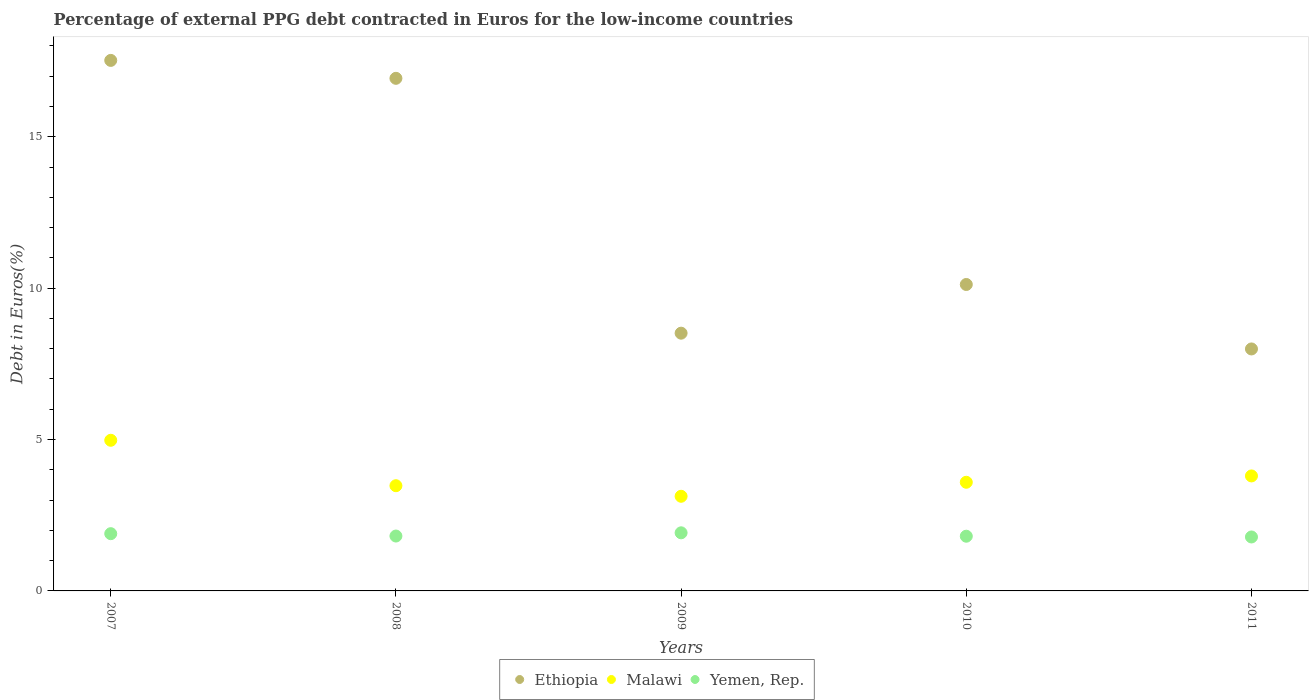What is the percentage of external PPG debt contracted in Euros in Ethiopia in 2009?
Offer a very short reply. 8.51. Across all years, what is the maximum percentage of external PPG debt contracted in Euros in Yemen, Rep.?
Make the answer very short. 1.92. Across all years, what is the minimum percentage of external PPG debt contracted in Euros in Ethiopia?
Your answer should be compact. 7.99. In which year was the percentage of external PPG debt contracted in Euros in Malawi maximum?
Provide a short and direct response. 2007. In which year was the percentage of external PPG debt contracted in Euros in Yemen, Rep. minimum?
Provide a short and direct response. 2011. What is the total percentage of external PPG debt contracted in Euros in Malawi in the graph?
Provide a succinct answer. 18.96. What is the difference between the percentage of external PPG debt contracted in Euros in Malawi in 2007 and that in 2010?
Provide a succinct answer. 1.39. What is the difference between the percentage of external PPG debt contracted in Euros in Malawi in 2007 and the percentage of external PPG debt contracted in Euros in Ethiopia in 2010?
Offer a terse response. -5.15. What is the average percentage of external PPG debt contracted in Euros in Ethiopia per year?
Make the answer very short. 12.22. In the year 2007, what is the difference between the percentage of external PPG debt contracted in Euros in Yemen, Rep. and percentage of external PPG debt contracted in Euros in Malawi?
Provide a succinct answer. -3.08. What is the ratio of the percentage of external PPG debt contracted in Euros in Malawi in 2007 to that in 2011?
Your answer should be very brief. 1.31. Is the percentage of external PPG debt contracted in Euros in Ethiopia in 2008 less than that in 2009?
Offer a very short reply. No. What is the difference between the highest and the second highest percentage of external PPG debt contracted in Euros in Yemen, Rep.?
Ensure brevity in your answer.  0.03. What is the difference between the highest and the lowest percentage of external PPG debt contracted in Euros in Malawi?
Provide a short and direct response. 1.85. Is it the case that in every year, the sum of the percentage of external PPG debt contracted in Euros in Malawi and percentage of external PPG debt contracted in Euros in Ethiopia  is greater than the percentage of external PPG debt contracted in Euros in Yemen, Rep.?
Make the answer very short. Yes. How many dotlines are there?
Offer a very short reply. 3. What is the difference between two consecutive major ticks on the Y-axis?
Offer a terse response. 5. Does the graph contain any zero values?
Keep it short and to the point. No. How many legend labels are there?
Provide a succinct answer. 3. What is the title of the graph?
Your response must be concise. Percentage of external PPG debt contracted in Euros for the low-income countries. What is the label or title of the Y-axis?
Keep it short and to the point. Debt in Euros(%). What is the Debt in Euros(%) in Ethiopia in 2007?
Provide a short and direct response. 17.52. What is the Debt in Euros(%) of Malawi in 2007?
Your answer should be very brief. 4.98. What is the Debt in Euros(%) in Yemen, Rep. in 2007?
Offer a very short reply. 1.89. What is the Debt in Euros(%) in Ethiopia in 2008?
Ensure brevity in your answer.  16.93. What is the Debt in Euros(%) of Malawi in 2008?
Offer a very short reply. 3.47. What is the Debt in Euros(%) in Yemen, Rep. in 2008?
Keep it short and to the point. 1.81. What is the Debt in Euros(%) in Ethiopia in 2009?
Give a very brief answer. 8.51. What is the Debt in Euros(%) of Malawi in 2009?
Keep it short and to the point. 3.13. What is the Debt in Euros(%) in Yemen, Rep. in 2009?
Your answer should be very brief. 1.92. What is the Debt in Euros(%) of Ethiopia in 2010?
Provide a short and direct response. 10.12. What is the Debt in Euros(%) of Malawi in 2010?
Your answer should be very brief. 3.59. What is the Debt in Euros(%) of Yemen, Rep. in 2010?
Give a very brief answer. 1.81. What is the Debt in Euros(%) in Ethiopia in 2011?
Provide a short and direct response. 7.99. What is the Debt in Euros(%) in Malawi in 2011?
Your answer should be very brief. 3.8. What is the Debt in Euros(%) of Yemen, Rep. in 2011?
Make the answer very short. 1.78. Across all years, what is the maximum Debt in Euros(%) in Ethiopia?
Keep it short and to the point. 17.52. Across all years, what is the maximum Debt in Euros(%) in Malawi?
Provide a succinct answer. 4.98. Across all years, what is the maximum Debt in Euros(%) of Yemen, Rep.?
Your answer should be compact. 1.92. Across all years, what is the minimum Debt in Euros(%) of Ethiopia?
Give a very brief answer. 7.99. Across all years, what is the minimum Debt in Euros(%) in Malawi?
Keep it short and to the point. 3.13. Across all years, what is the minimum Debt in Euros(%) of Yemen, Rep.?
Provide a succinct answer. 1.78. What is the total Debt in Euros(%) of Ethiopia in the graph?
Your response must be concise. 61.08. What is the total Debt in Euros(%) in Malawi in the graph?
Provide a short and direct response. 18.96. What is the total Debt in Euros(%) of Yemen, Rep. in the graph?
Provide a succinct answer. 9.21. What is the difference between the Debt in Euros(%) in Ethiopia in 2007 and that in 2008?
Your answer should be compact. 0.59. What is the difference between the Debt in Euros(%) of Malawi in 2007 and that in 2008?
Provide a succinct answer. 1.5. What is the difference between the Debt in Euros(%) of Yemen, Rep. in 2007 and that in 2008?
Make the answer very short. 0.08. What is the difference between the Debt in Euros(%) of Ethiopia in 2007 and that in 2009?
Your answer should be compact. 9.01. What is the difference between the Debt in Euros(%) in Malawi in 2007 and that in 2009?
Ensure brevity in your answer.  1.85. What is the difference between the Debt in Euros(%) in Yemen, Rep. in 2007 and that in 2009?
Give a very brief answer. -0.03. What is the difference between the Debt in Euros(%) in Ethiopia in 2007 and that in 2010?
Your answer should be compact. 7.4. What is the difference between the Debt in Euros(%) of Malawi in 2007 and that in 2010?
Your answer should be very brief. 1.39. What is the difference between the Debt in Euros(%) of Yemen, Rep. in 2007 and that in 2010?
Provide a succinct answer. 0.08. What is the difference between the Debt in Euros(%) of Ethiopia in 2007 and that in 2011?
Your answer should be compact. 9.53. What is the difference between the Debt in Euros(%) in Malawi in 2007 and that in 2011?
Your answer should be compact. 1.18. What is the difference between the Debt in Euros(%) of Yemen, Rep. in 2007 and that in 2011?
Keep it short and to the point. 0.11. What is the difference between the Debt in Euros(%) of Ethiopia in 2008 and that in 2009?
Make the answer very short. 8.42. What is the difference between the Debt in Euros(%) in Malawi in 2008 and that in 2009?
Your answer should be compact. 0.35. What is the difference between the Debt in Euros(%) in Yemen, Rep. in 2008 and that in 2009?
Give a very brief answer. -0.11. What is the difference between the Debt in Euros(%) in Ethiopia in 2008 and that in 2010?
Ensure brevity in your answer.  6.81. What is the difference between the Debt in Euros(%) of Malawi in 2008 and that in 2010?
Offer a terse response. -0.11. What is the difference between the Debt in Euros(%) of Yemen, Rep. in 2008 and that in 2010?
Offer a terse response. 0.01. What is the difference between the Debt in Euros(%) of Ethiopia in 2008 and that in 2011?
Provide a short and direct response. 8.94. What is the difference between the Debt in Euros(%) in Malawi in 2008 and that in 2011?
Offer a very short reply. -0.32. What is the difference between the Debt in Euros(%) of Yemen, Rep. in 2008 and that in 2011?
Keep it short and to the point. 0.03. What is the difference between the Debt in Euros(%) in Ethiopia in 2009 and that in 2010?
Offer a terse response. -1.61. What is the difference between the Debt in Euros(%) in Malawi in 2009 and that in 2010?
Ensure brevity in your answer.  -0.46. What is the difference between the Debt in Euros(%) of Yemen, Rep. in 2009 and that in 2010?
Your response must be concise. 0.11. What is the difference between the Debt in Euros(%) in Ethiopia in 2009 and that in 2011?
Your answer should be compact. 0.52. What is the difference between the Debt in Euros(%) in Malawi in 2009 and that in 2011?
Make the answer very short. -0.67. What is the difference between the Debt in Euros(%) of Yemen, Rep. in 2009 and that in 2011?
Provide a succinct answer. 0.14. What is the difference between the Debt in Euros(%) in Ethiopia in 2010 and that in 2011?
Offer a very short reply. 2.13. What is the difference between the Debt in Euros(%) in Malawi in 2010 and that in 2011?
Provide a succinct answer. -0.21. What is the difference between the Debt in Euros(%) in Yemen, Rep. in 2010 and that in 2011?
Make the answer very short. 0.03. What is the difference between the Debt in Euros(%) in Ethiopia in 2007 and the Debt in Euros(%) in Malawi in 2008?
Your answer should be very brief. 14.05. What is the difference between the Debt in Euros(%) in Ethiopia in 2007 and the Debt in Euros(%) in Yemen, Rep. in 2008?
Provide a succinct answer. 15.71. What is the difference between the Debt in Euros(%) of Malawi in 2007 and the Debt in Euros(%) of Yemen, Rep. in 2008?
Offer a terse response. 3.16. What is the difference between the Debt in Euros(%) in Ethiopia in 2007 and the Debt in Euros(%) in Malawi in 2009?
Your response must be concise. 14.4. What is the difference between the Debt in Euros(%) of Ethiopia in 2007 and the Debt in Euros(%) of Yemen, Rep. in 2009?
Make the answer very short. 15.6. What is the difference between the Debt in Euros(%) in Malawi in 2007 and the Debt in Euros(%) in Yemen, Rep. in 2009?
Keep it short and to the point. 3.06. What is the difference between the Debt in Euros(%) in Ethiopia in 2007 and the Debt in Euros(%) in Malawi in 2010?
Offer a very short reply. 13.93. What is the difference between the Debt in Euros(%) in Ethiopia in 2007 and the Debt in Euros(%) in Yemen, Rep. in 2010?
Give a very brief answer. 15.72. What is the difference between the Debt in Euros(%) in Malawi in 2007 and the Debt in Euros(%) in Yemen, Rep. in 2010?
Offer a very short reply. 3.17. What is the difference between the Debt in Euros(%) in Ethiopia in 2007 and the Debt in Euros(%) in Malawi in 2011?
Provide a succinct answer. 13.72. What is the difference between the Debt in Euros(%) in Ethiopia in 2007 and the Debt in Euros(%) in Yemen, Rep. in 2011?
Ensure brevity in your answer.  15.74. What is the difference between the Debt in Euros(%) in Malawi in 2007 and the Debt in Euros(%) in Yemen, Rep. in 2011?
Your response must be concise. 3.19. What is the difference between the Debt in Euros(%) of Ethiopia in 2008 and the Debt in Euros(%) of Malawi in 2009?
Your answer should be compact. 13.8. What is the difference between the Debt in Euros(%) of Ethiopia in 2008 and the Debt in Euros(%) of Yemen, Rep. in 2009?
Offer a very short reply. 15.01. What is the difference between the Debt in Euros(%) in Malawi in 2008 and the Debt in Euros(%) in Yemen, Rep. in 2009?
Provide a succinct answer. 1.56. What is the difference between the Debt in Euros(%) in Ethiopia in 2008 and the Debt in Euros(%) in Malawi in 2010?
Your response must be concise. 13.34. What is the difference between the Debt in Euros(%) in Ethiopia in 2008 and the Debt in Euros(%) in Yemen, Rep. in 2010?
Keep it short and to the point. 15.12. What is the difference between the Debt in Euros(%) of Malawi in 2008 and the Debt in Euros(%) of Yemen, Rep. in 2010?
Keep it short and to the point. 1.67. What is the difference between the Debt in Euros(%) in Ethiopia in 2008 and the Debt in Euros(%) in Malawi in 2011?
Give a very brief answer. 13.13. What is the difference between the Debt in Euros(%) in Ethiopia in 2008 and the Debt in Euros(%) in Yemen, Rep. in 2011?
Keep it short and to the point. 15.15. What is the difference between the Debt in Euros(%) of Malawi in 2008 and the Debt in Euros(%) of Yemen, Rep. in 2011?
Your answer should be compact. 1.69. What is the difference between the Debt in Euros(%) of Ethiopia in 2009 and the Debt in Euros(%) of Malawi in 2010?
Ensure brevity in your answer.  4.92. What is the difference between the Debt in Euros(%) in Ethiopia in 2009 and the Debt in Euros(%) in Yemen, Rep. in 2010?
Your answer should be very brief. 6.71. What is the difference between the Debt in Euros(%) of Malawi in 2009 and the Debt in Euros(%) of Yemen, Rep. in 2010?
Make the answer very short. 1.32. What is the difference between the Debt in Euros(%) in Ethiopia in 2009 and the Debt in Euros(%) in Malawi in 2011?
Provide a succinct answer. 4.72. What is the difference between the Debt in Euros(%) in Ethiopia in 2009 and the Debt in Euros(%) in Yemen, Rep. in 2011?
Give a very brief answer. 6.73. What is the difference between the Debt in Euros(%) in Malawi in 2009 and the Debt in Euros(%) in Yemen, Rep. in 2011?
Offer a very short reply. 1.34. What is the difference between the Debt in Euros(%) in Ethiopia in 2010 and the Debt in Euros(%) in Malawi in 2011?
Offer a terse response. 6.32. What is the difference between the Debt in Euros(%) in Ethiopia in 2010 and the Debt in Euros(%) in Yemen, Rep. in 2011?
Provide a succinct answer. 8.34. What is the difference between the Debt in Euros(%) in Malawi in 2010 and the Debt in Euros(%) in Yemen, Rep. in 2011?
Offer a very short reply. 1.81. What is the average Debt in Euros(%) in Ethiopia per year?
Offer a terse response. 12.22. What is the average Debt in Euros(%) in Malawi per year?
Keep it short and to the point. 3.79. What is the average Debt in Euros(%) in Yemen, Rep. per year?
Your answer should be compact. 1.84. In the year 2007, what is the difference between the Debt in Euros(%) of Ethiopia and Debt in Euros(%) of Malawi?
Offer a terse response. 12.55. In the year 2007, what is the difference between the Debt in Euros(%) of Ethiopia and Debt in Euros(%) of Yemen, Rep.?
Ensure brevity in your answer.  15.63. In the year 2007, what is the difference between the Debt in Euros(%) in Malawi and Debt in Euros(%) in Yemen, Rep.?
Offer a very short reply. 3.08. In the year 2008, what is the difference between the Debt in Euros(%) in Ethiopia and Debt in Euros(%) in Malawi?
Offer a terse response. 13.46. In the year 2008, what is the difference between the Debt in Euros(%) in Ethiopia and Debt in Euros(%) in Yemen, Rep.?
Provide a short and direct response. 15.12. In the year 2008, what is the difference between the Debt in Euros(%) in Malawi and Debt in Euros(%) in Yemen, Rep.?
Give a very brief answer. 1.66. In the year 2009, what is the difference between the Debt in Euros(%) in Ethiopia and Debt in Euros(%) in Malawi?
Offer a terse response. 5.39. In the year 2009, what is the difference between the Debt in Euros(%) in Ethiopia and Debt in Euros(%) in Yemen, Rep.?
Make the answer very short. 6.59. In the year 2009, what is the difference between the Debt in Euros(%) of Malawi and Debt in Euros(%) of Yemen, Rep.?
Provide a short and direct response. 1.21. In the year 2010, what is the difference between the Debt in Euros(%) of Ethiopia and Debt in Euros(%) of Malawi?
Provide a succinct answer. 6.53. In the year 2010, what is the difference between the Debt in Euros(%) of Ethiopia and Debt in Euros(%) of Yemen, Rep.?
Your answer should be very brief. 8.31. In the year 2010, what is the difference between the Debt in Euros(%) of Malawi and Debt in Euros(%) of Yemen, Rep.?
Provide a short and direct response. 1.78. In the year 2011, what is the difference between the Debt in Euros(%) in Ethiopia and Debt in Euros(%) in Malawi?
Your answer should be compact. 4.19. In the year 2011, what is the difference between the Debt in Euros(%) of Ethiopia and Debt in Euros(%) of Yemen, Rep.?
Your answer should be compact. 6.21. In the year 2011, what is the difference between the Debt in Euros(%) in Malawi and Debt in Euros(%) in Yemen, Rep.?
Give a very brief answer. 2.02. What is the ratio of the Debt in Euros(%) of Ethiopia in 2007 to that in 2008?
Ensure brevity in your answer.  1.03. What is the ratio of the Debt in Euros(%) of Malawi in 2007 to that in 2008?
Provide a succinct answer. 1.43. What is the ratio of the Debt in Euros(%) in Yemen, Rep. in 2007 to that in 2008?
Make the answer very short. 1.04. What is the ratio of the Debt in Euros(%) in Ethiopia in 2007 to that in 2009?
Your response must be concise. 2.06. What is the ratio of the Debt in Euros(%) in Malawi in 2007 to that in 2009?
Ensure brevity in your answer.  1.59. What is the ratio of the Debt in Euros(%) in Yemen, Rep. in 2007 to that in 2009?
Ensure brevity in your answer.  0.99. What is the ratio of the Debt in Euros(%) in Ethiopia in 2007 to that in 2010?
Your answer should be very brief. 1.73. What is the ratio of the Debt in Euros(%) of Malawi in 2007 to that in 2010?
Your response must be concise. 1.39. What is the ratio of the Debt in Euros(%) of Yemen, Rep. in 2007 to that in 2010?
Your answer should be very brief. 1.05. What is the ratio of the Debt in Euros(%) of Ethiopia in 2007 to that in 2011?
Ensure brevity in your answer.  2.19. What is the ratio of the Debt in Euros(%) in Malawi in 2007 to that in 2011?
Provide a short and direct response. 1.31. What is the ratio of the Debt in Euros(%) in Yemen, Rep. in 2007 to that in 2011?
Your answer should be very brief. 1.06. What is the ratio of the Debt in Euros(%) in Ethiopia in 2008 to that in 2009?
Provide a short and direct response. 1.99. What is the ratio of the Debt in Euros(%) of Malawi in 2008 to that in 2009?
Give a very brief answer. 1.11. What is the ratio of the Debt in Euros(%) in Yemen, Rep. in 2008 to that in 2009?
Offer a very short reply. 0.94. What is the ratio of the Debt in Euros(%) of Ethiopia in 2008 to that in 2010?
Offer a terse response. 1.67. What is the ratio of the Debt in Euros(%) in Malawi in 2008 to that in 2010?
Your answer should be compact. 0.97. What is the ratio of the Debt in Euros(%) of Ethiopia in 2008 to that in 2011?
Provide a short and direct response. 2.12. What is the ratio of the Debt in Euros(%) in Malawi in 2008 to that in 2011?
Make the answer very short. 0.92. What is the ratio of the Debt in Euros(%) of Yemen, Rep. in 2008 to that in 2011?
Keep it short and to the point. 1.02. What is the ratio of the Debt in Euros(%) in Ethiopia in 2009 to that in 2010?
Your answer should be very brief. 0.84. What is the ratio of the Debt in Euros(%) in Malawi in 2009 to that in 2010?
Your answer should be compact. 0.87. What is the ratio of the Debt in Euros(%) in Yemen, Rep. in 2009 to that in 2010?
Keep it short and to the point. 1.06. What is the ratio of the Debt in Euros(%) in Ethiopia in 2009 to that in 2011?
Offer a terse response. 1.07. What is the ratio of the Debt in Euros(%) in Malawi in 2009 to that in 2011?
Offer a terse response. 0.82. What is the ratio of the Debt in Euros(%) in Yemen, Rep. in 2009 to that in 2011?
Offer a very short reply. 1.08. What is the ratio of the Debt in Euros(%) of Ethiopia in 2010 to that in 2011?
Your answer should be compact. 1.27. What is the ratio of the Debt in Euros(%) of Malawi in 2010 to that in 2011?
Offer a very short reply. 0.94. What is the difference between the highest and the second highest Debt in Euros(%) of Ethiopia?
Your answer should be compact. 0.59. What is the difference between the highest and the second highest Debt in Euros(%) of Malawi?
Provide a short and direct response. 1.18. What is the difference between the highest and the second highest Debt in Euros(%) in Yemen, Rep.?
Give a very brief answer. 0.03. What is the difference between the highest and the lowest Debt in Euros(%) in Ethiopia?
Make the answer very short. 9.53. What is the difference between the highest and the lowest Debt in Euros(%) in Malawi?
Provide a succinct answer. 1.85. What is the difference between the highest and the lowest Debt in Euros(%) of Yemen, Rep.?
Provide a short and direct response. 0.14. 